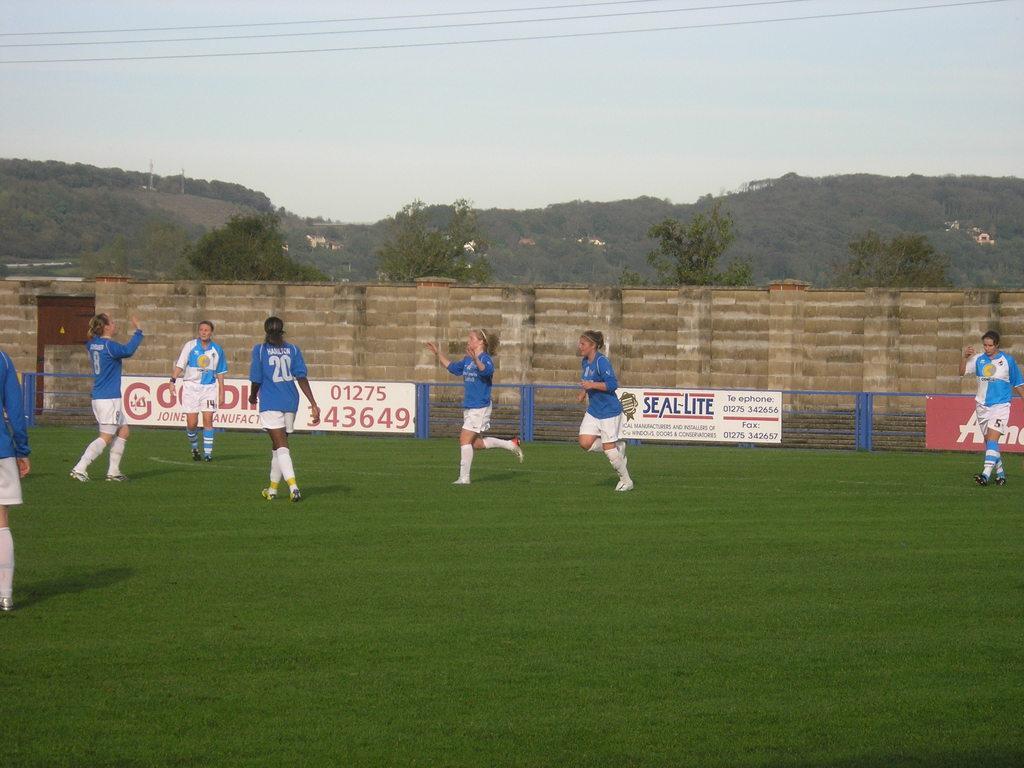Please provide a concise description of this image. In the picture we can see a playground on it, we can see some people in a sportswear and in the background, we can see a wall with some advertisements on it and behind the wall we can see some trees, hills and sky. 